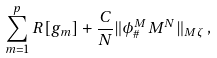<formula> <loc_0><loc_0><loc_500><loc_500>\sum _ { m = 1 } ^ { p } R [ g _ { m } ] + \frac { C } { N } \| \phi ^ { M } _ { \# } M ^ { N } \| _ { M \zeta } \, ,</formula> 